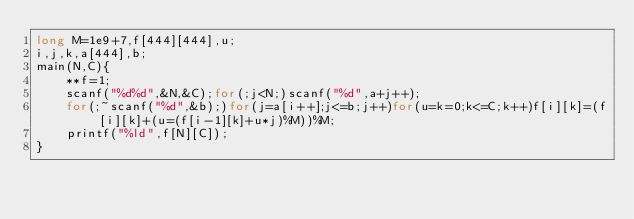Convert code to text. <code><loc_0><loc_0><loc_500><loc_500><_C_>long M=1e9+7,f[444][444],u;
i,j,k,a[444],b;
main(N,C){
	**f=1;
	scanf("%d%d",&N,&C);for(;j<N;)scanf("%d",a+j++);
	for(;~scanf("%d",&b);)for(j=a[i++];j<=b;j++)for(u=k=0;k<=C;k++)f[i][k]=(f[i][k]+(u=(f[i-1][k]+u*j)%M))%M;
	printf("%ld",f[N][C]);
}</code> 